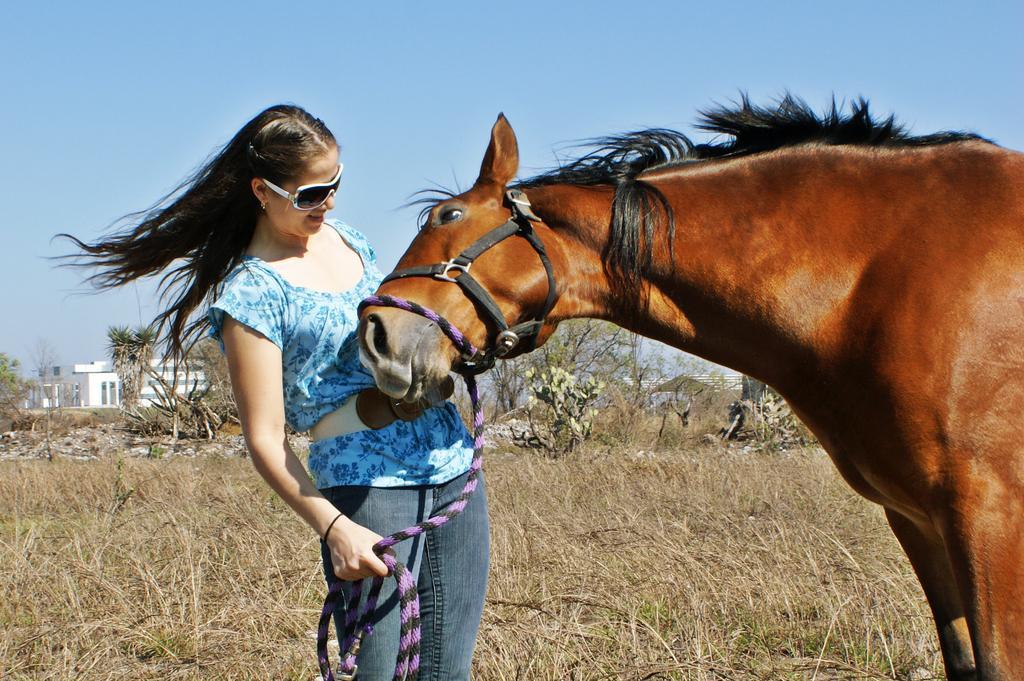Please provide a concise description of this image. In the image we can see there is a woman standing and she is holding rope in her hand which is tied to the horse. The horse is standing on the ground and the ground is covered with dry plants. Behind there is building and there are trees. There is a clear sky. 